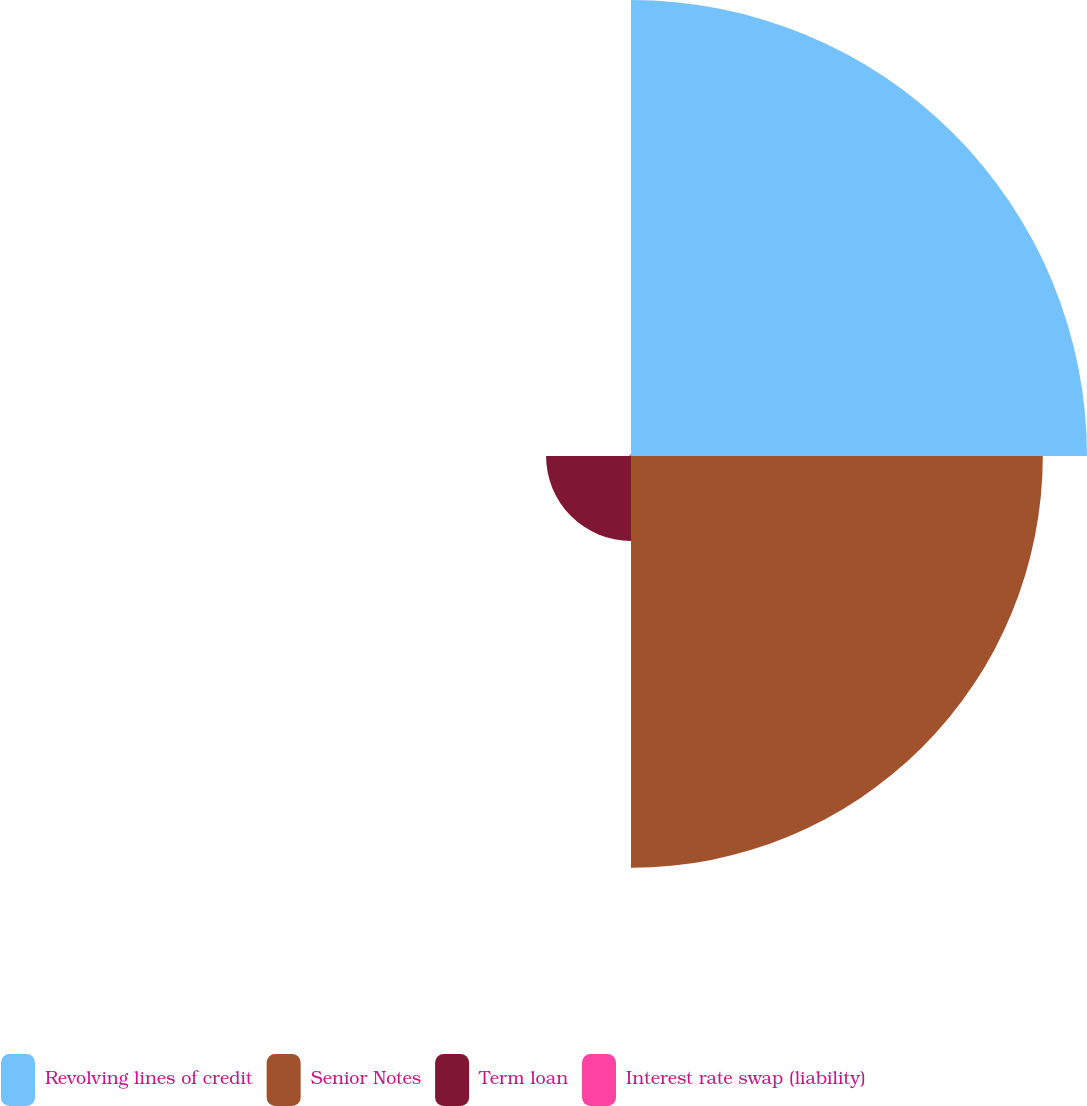Convert chart. <chart><loc_0><loc_0><loc_500><loc_500><pie_chart><fcel>Revolving lines of credit<fcel>Senior Notes<fcel>Term loan<fcel>Interest rate swap (liability)<nl><fcel>47.78%<fcel>43.15%<fcel>8.9%<fcel>0.18%<nl></chart> 